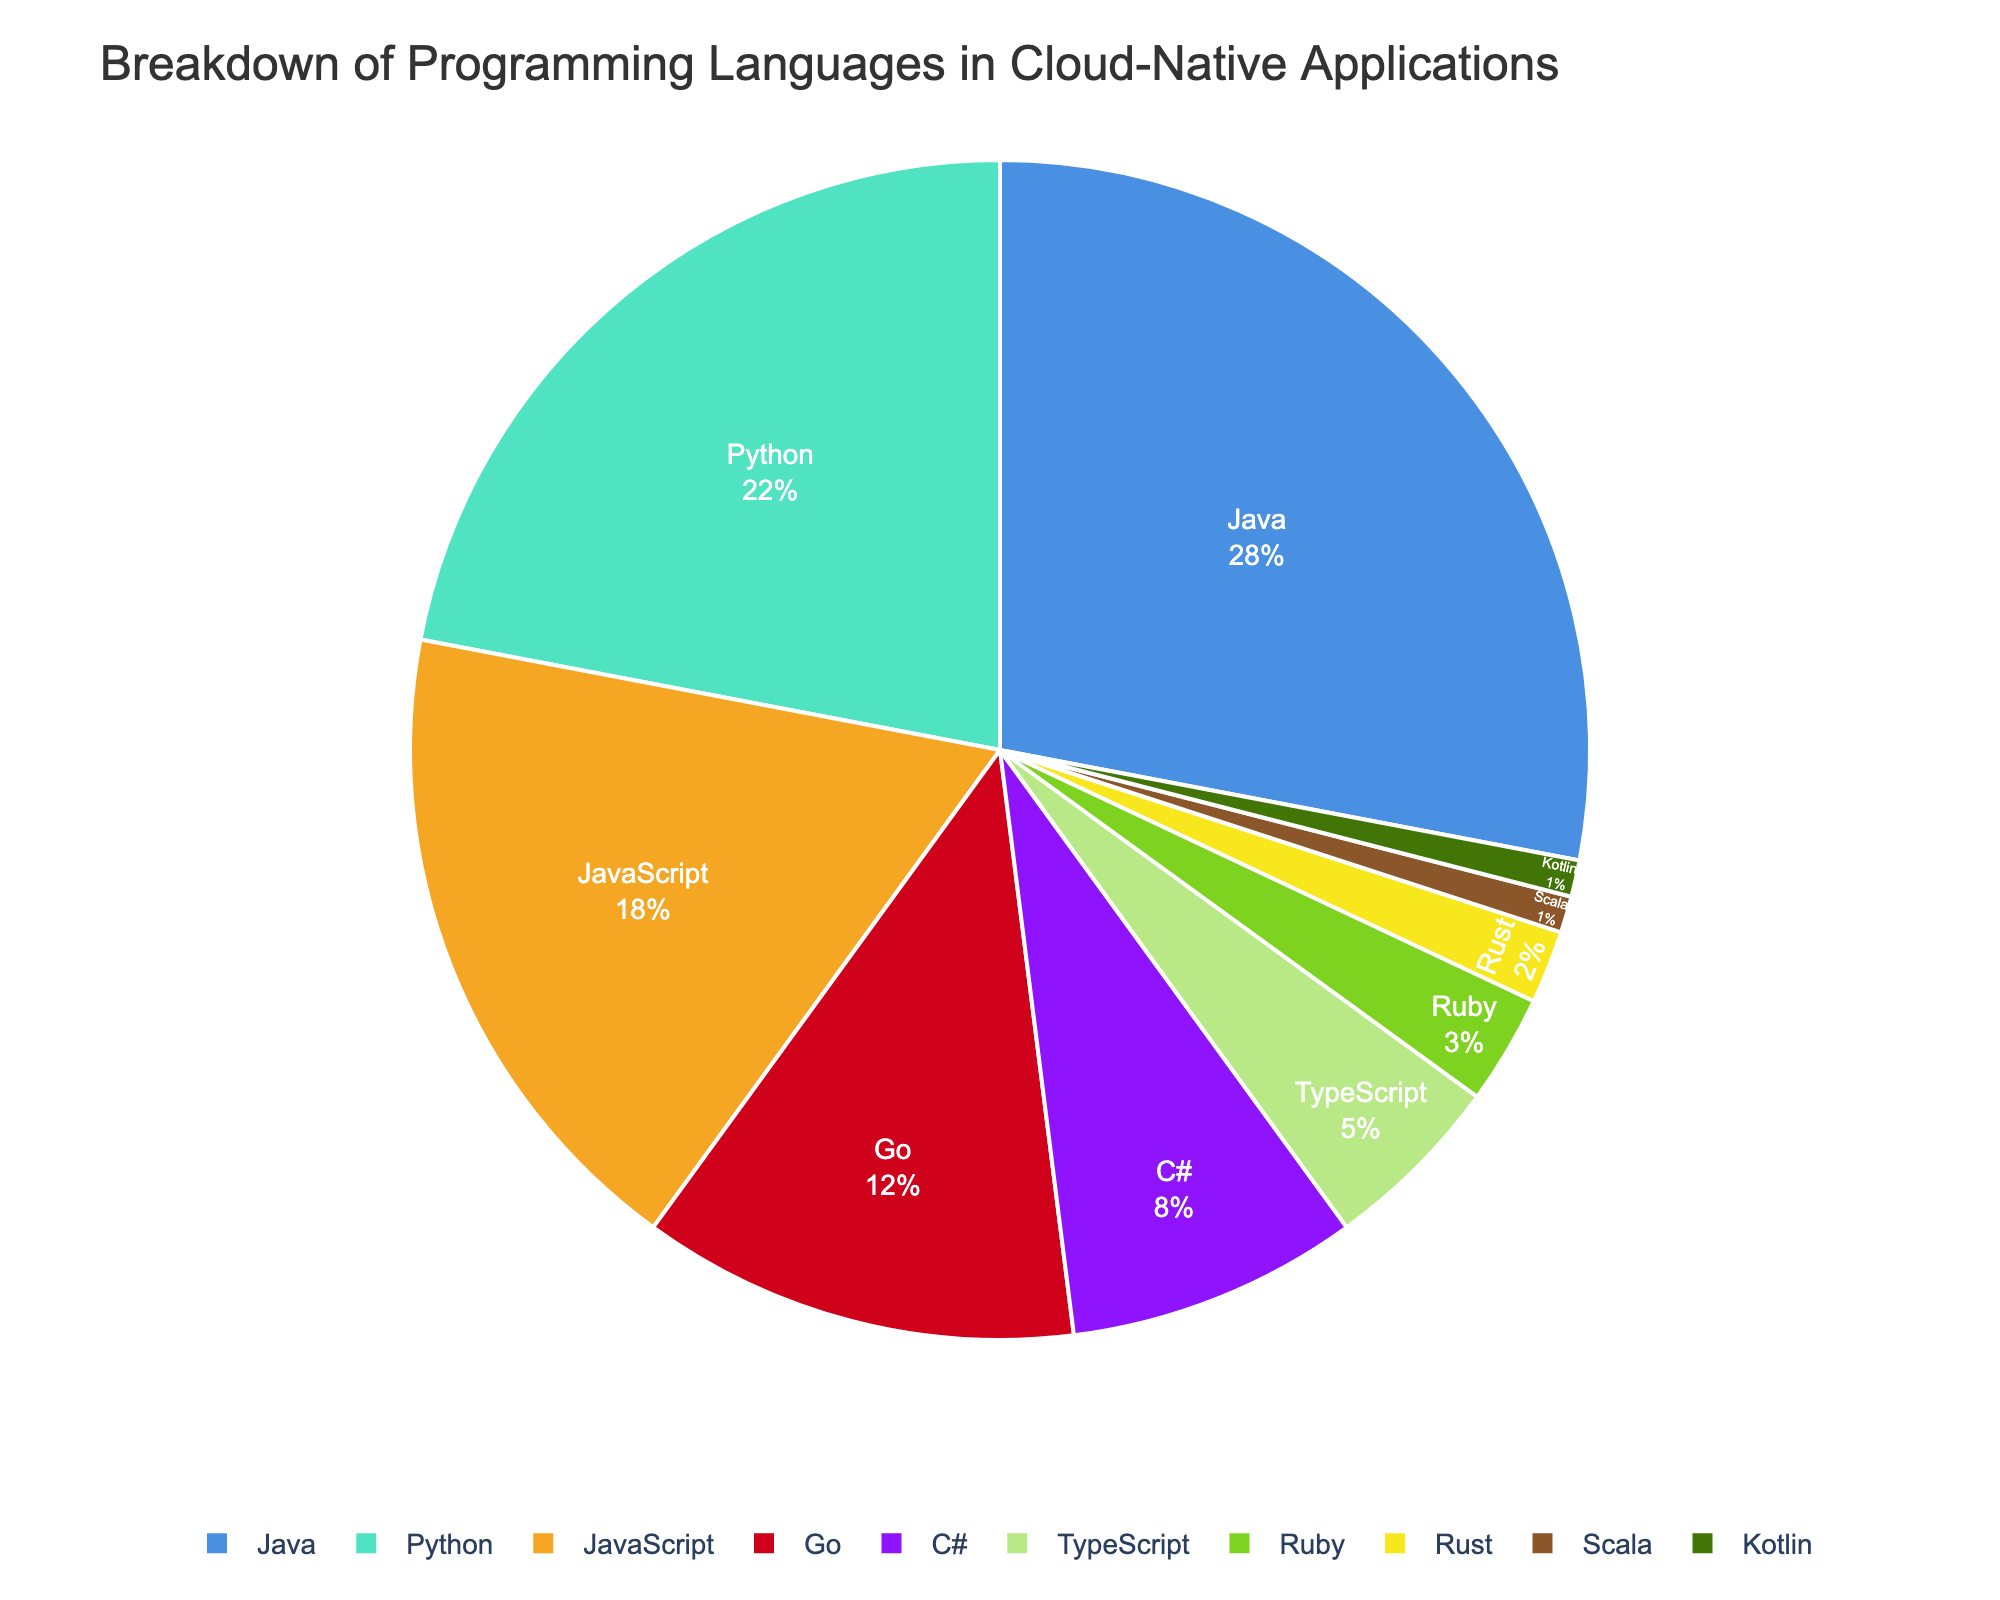Which programming language is used the most in cloud-native applications? Look for the programming language with the highest percentage. Java has the largest slice of the pie chart.
Answer: Java Which two languages combined make up an equal percentage to Python alone? Python has a 22% share. Look for two languages whose combined percentages equal 22%. JavaScript (18%) and Rust (2%) together account for 20%, which along with TypeScript (5%), sum up to 23%, so close combinations should be considered. Given the data strictly, no two languages match exactly.
Answer: None How does Go’s usage compare to Ruby’s usage? Compare the percentage values of Go and Ruby. Go is at 12% and Ruby is at 3%.
Answer: Go usage is 4 times Ruby usage Which three languages make up less than 10% of the total usage? Identify languages with percentages adding to less than 10%. Ruby (3%), Rust (2%), Scala (1%), and Kotlin (1%).
Answer: Ruby, Rust, Scala, Kotlin What is the difference in percentage between the most and least used languages? Subtract the percentage of the least used language (Kotlin, 1%) from the percentage of the most used language (Java, 28%).
Answer: 27% What percentage of users prefer TypeScript over C# for cloud-native applications? Compare the percentages of TypeScript and C#, and calculate (8% - 5%).
Answer: 3% Are there more users using Python than JavaScript and TypeScript combined? Compare Python’s percentage (22%) with the sum of JavaScript and TypeScript (18% + 5% = 23%).
Answer: No Which language other than Java has the closest usage percentage to Go? Compare the percentage of Go (12%) with other languages except Java. Python has a closer usage percentage of 22%, being nearer than others if considered relatively in total usage context but specifically by near value difference, JavaScript (18%) is closest.
Answer: JavaScript 